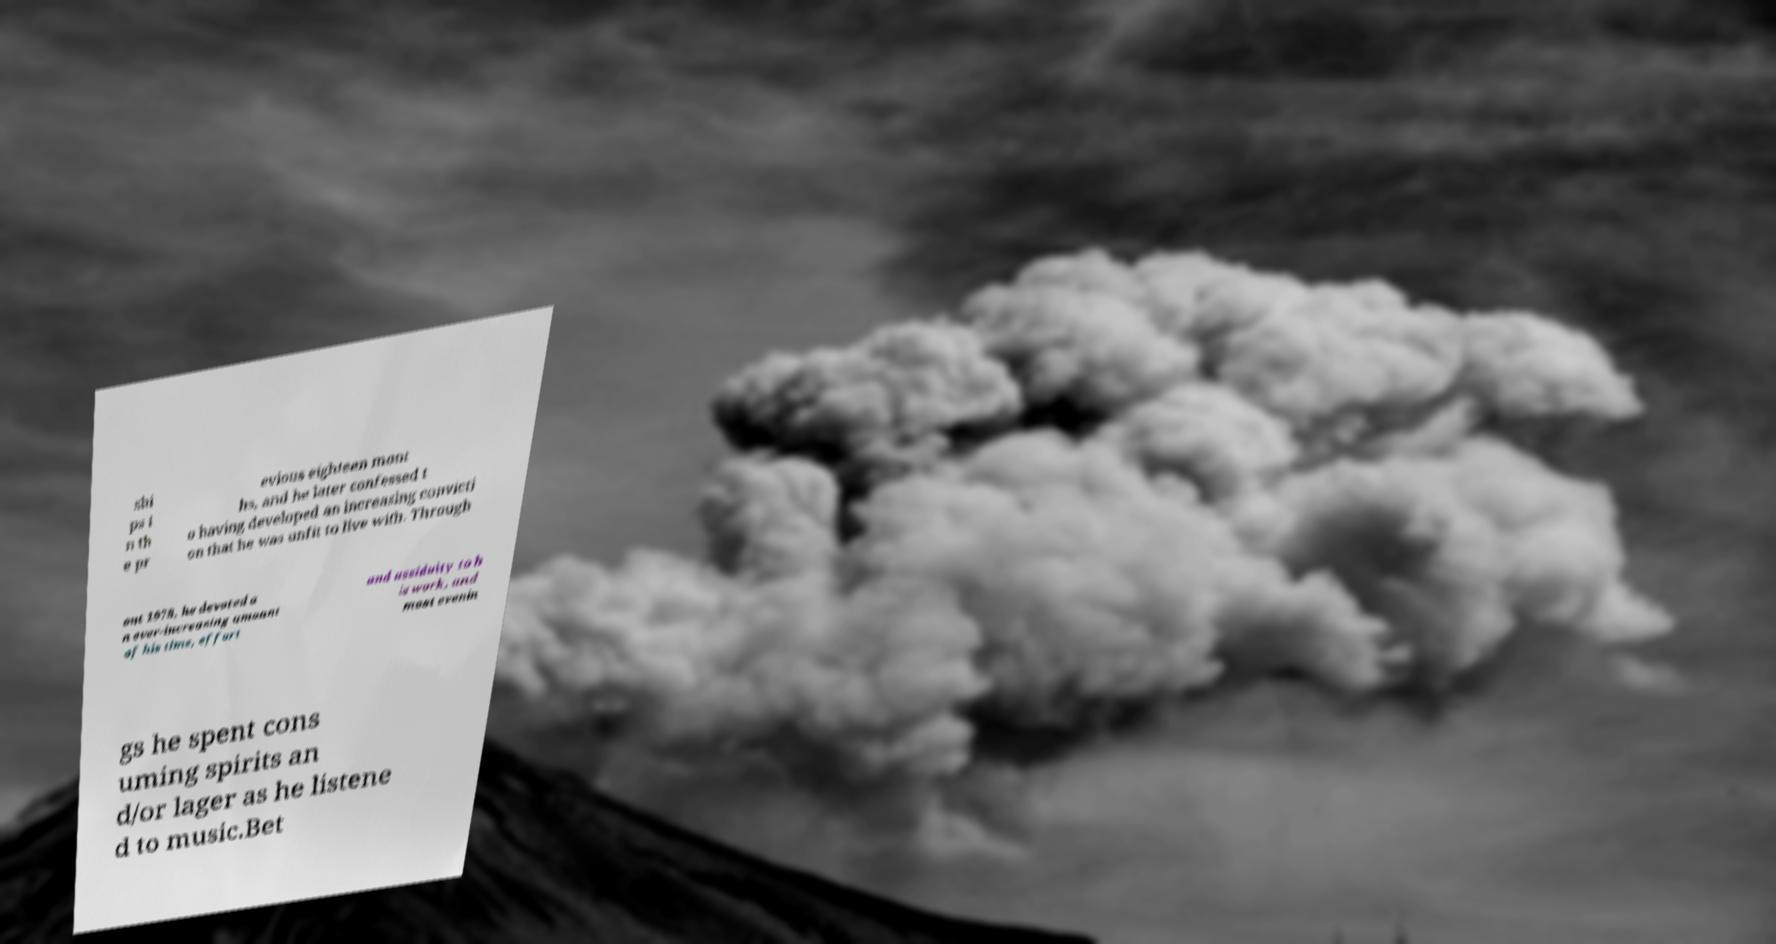For documentation purposes, I need the text within this image transcribed. Could you provide that? shi ps i n th e pr evious eighteen mont hs, and he later confessed t o having developed an increasing convicti on that he was unfit to live with. Through out 1978, he devoted a n ever-increasing amount of his time, effort and assiduity to h is work, and most evenin gs he spent cons uming spirits an d/or lager as he listene d to music.Bet 